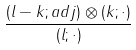Convert formula to latex. <formula><loc_0><loc_0><loc_500><loc_500>\frac { ( l - k ; a d j ) \otimes ( k ; \cdot ) } { ( l ; \cdot ) }</formula> 